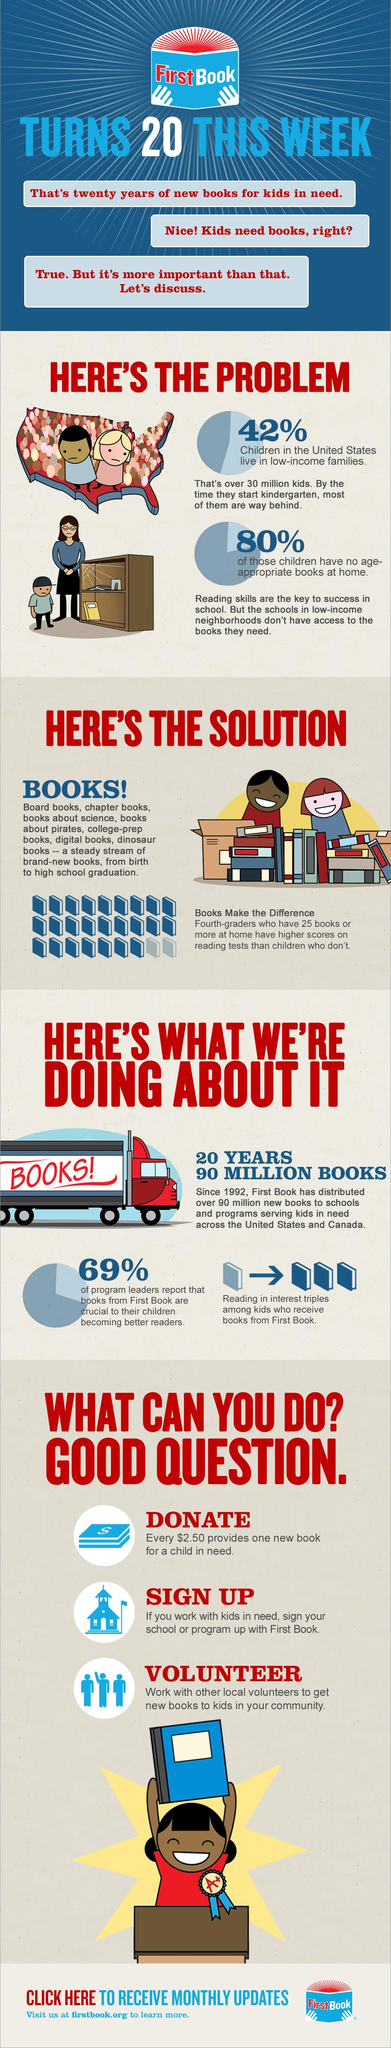Identify some key points in this picture. According to recent data, a significant majority of children in the United States, approximately 58%, do not live in low-income families. According to recent research, only 20% of children have age-appropriate books at home. 